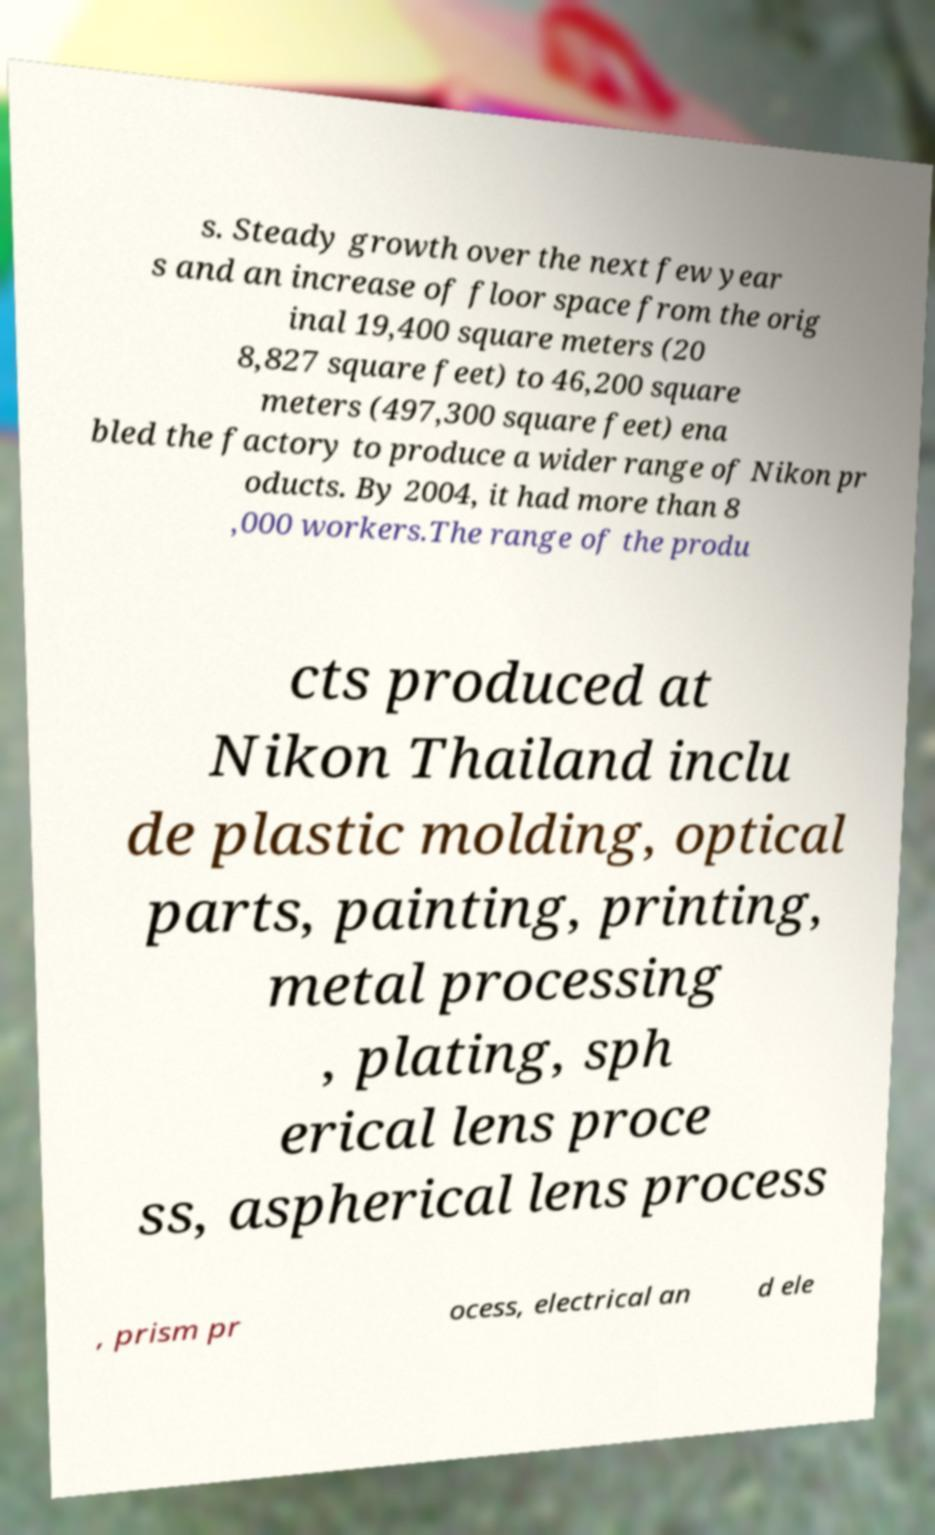I need the written content from this picture converted into text. Can you do that? s. Steady growth over the next few year s and an increase of floor space from the orig inal 19,400 square meters (20 8,827 square feet) to 46,200 square meters (497,300 square feet) ena bled the factory to produce a wider range of Nikon pr oducts. By 2004, it had more than 8 ,000 workers.The range of the produ cts produced at Nikon Thailand inclu de plastic molding, optical parts, painting, printing, metal processing , plating, sph erical lens proce ss, aspherical lens process , prism pr ocess, electrical an d ele 